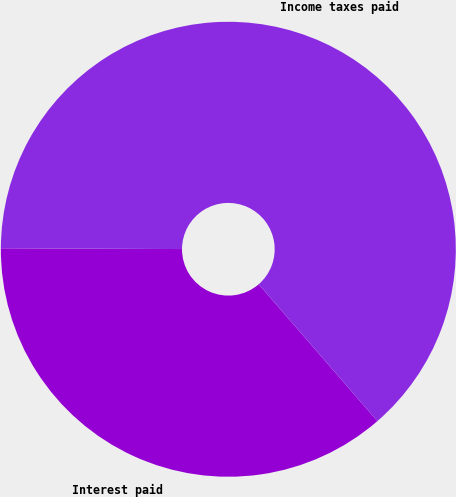Convert chart. <chart><loc_0><loc_0><loc_500><loc_500><pie_chart><fcel>Interest paid<fcel>Income taxes paid<nl><fcel>36.44%<fcel>63.56%<nl></chart> 